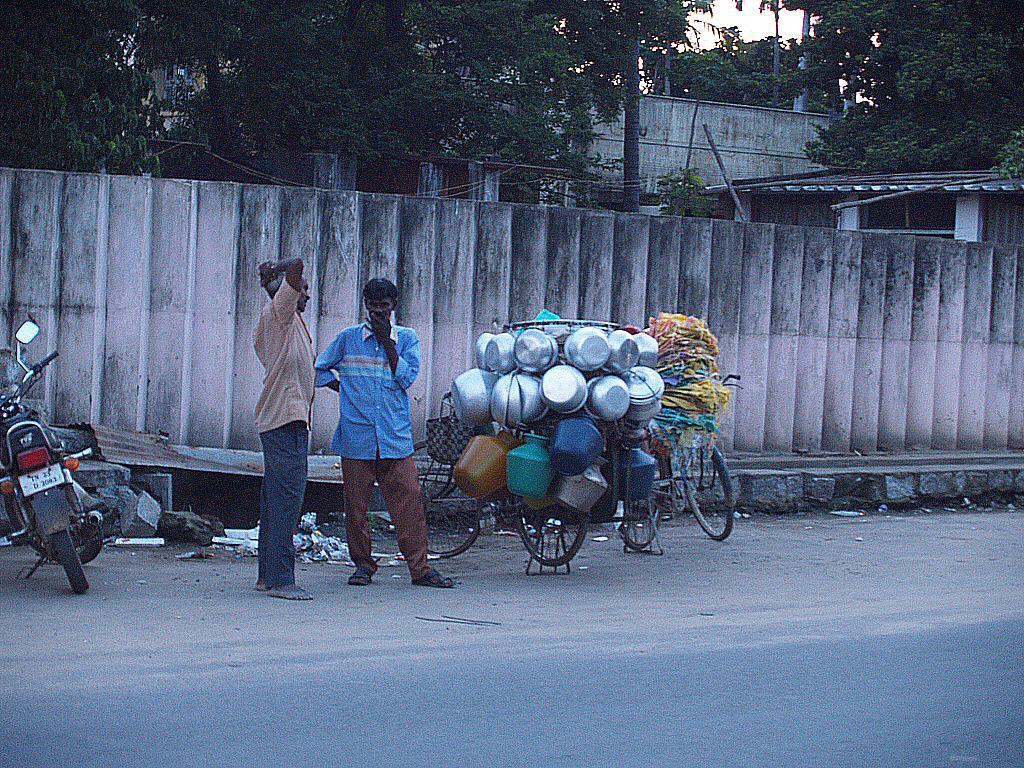Could you give a brief overview of what you see in this image? In this image we can see two persons standing on the road and there are bicycles with few objects beside a person and there is a motor cycle on the left side and in the background there is a wall, shed, few trees and the sky. 